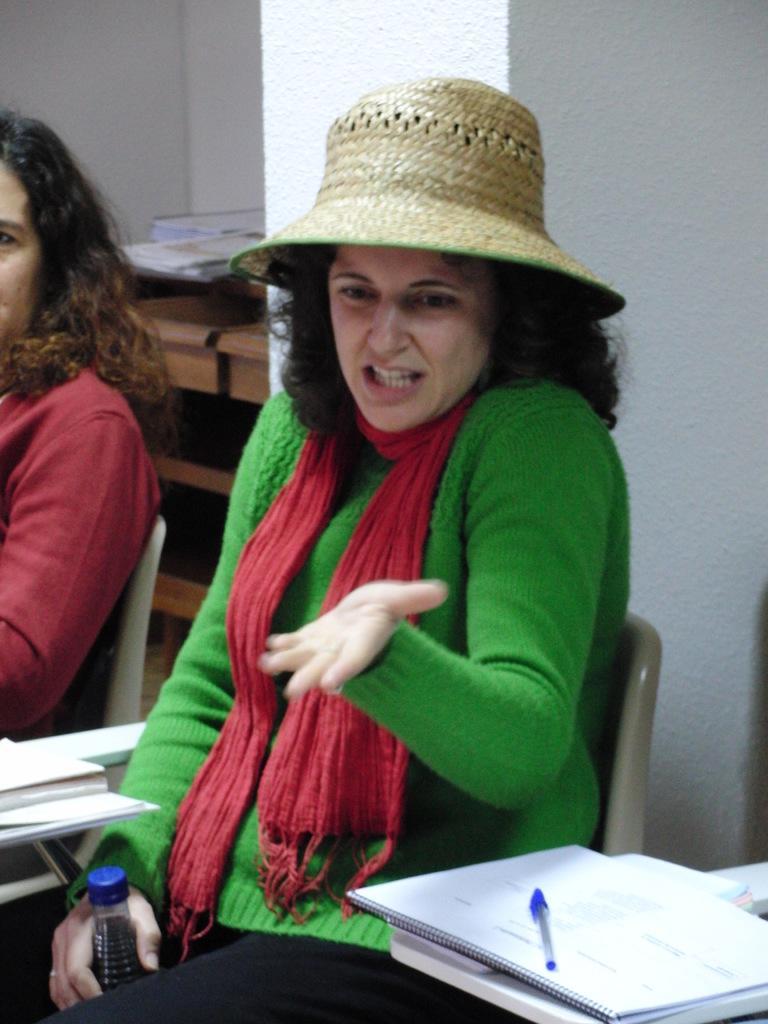Describe this image in one or two sentences. There is a lady sitting in the foreground area of the image, wearing a hat and holding a bottle in the foreground, there are books and a pen at the bottom side, there is another lady on the left side, it seems like cupboards and books in the background. 